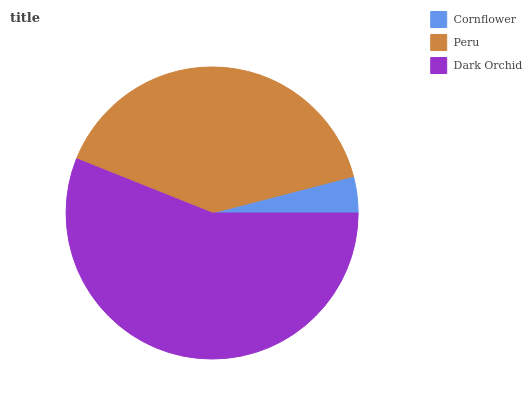Is Cornflower the minimum?
Answer yes or no. Yes. Is Dark Orchid the maximum?
Answer yes or no. Yes. Is Peru the minimum?
Answer yes or no. No. Is Peru the maximum?
Answer yes or no. No. Is Peru greater than Cornflower?
Answer yes or no. Yes. Is Cornflower less than Peru?
Answer yes or no. Yes. Is Cornflower greater than Peru?
Answer yes or no. No. Is Peru less than Cornflower?
Answer yes or no. No. Is Peru the high median?
Answer yes or no. Yes. Is Peru the low median?
Answer yes or no. Yes. Is Cornflower the high median?
Answer yes or no. No. Is Cornflower the low median?
Answer yes or no. No. 